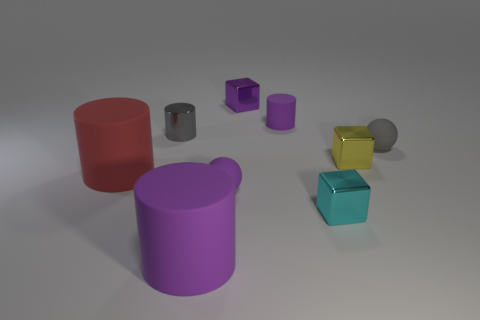Add 1 gray objects. How many objects exist? 10 Subtract all tiny purple cubes. How many cubes are left? 2 Subtract all cyan blocks. How many blocks are left? 2 Subtract all blocks. How many objects are left? 6 Subtract 1 balls. How many balls are left? 1 Subtract all cyan rubber balls. Subtract all balls. How many objects are left? 7 Add 1 small gray cylinders. How many small gray cylinders are left? 2 Add 1 tiny shiny objects. How many tiny shiny objects exist? 5 Subtract 1 yellow blocks. How many objects are left? 8 Subtract all cyan blocks. Subtract all blue cylinders. How many blocks are left? 2 